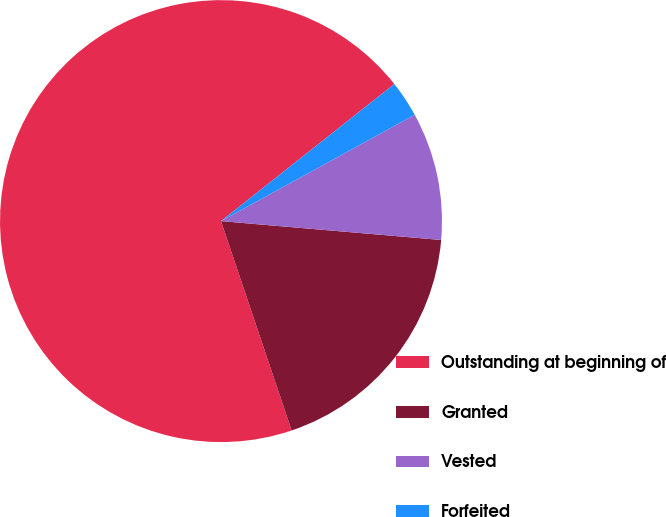Convert chart. <chart><loc_0><loc_0><loc_500><loc_500><pie_chart><fcel>Outstanding at beginning of<fcel>Granted<fcel>Vested<fcel>Forfeited<nl><fcel>69.53%<fcel>18.46%<fcel>9.35%<fcel>2.66%<nl></chart> 